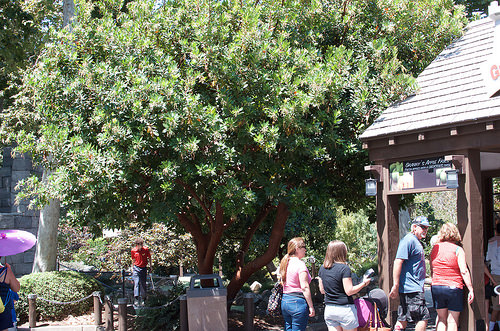<image>
Is the man under the tree? Yes. The man is positioned underneath the tree, with the tree above it in the vertical space. Is there a garbage can in front of the tree? Yes. The garbage can is positioned in front of the tree, appearing closer to the camera viewpoint. 